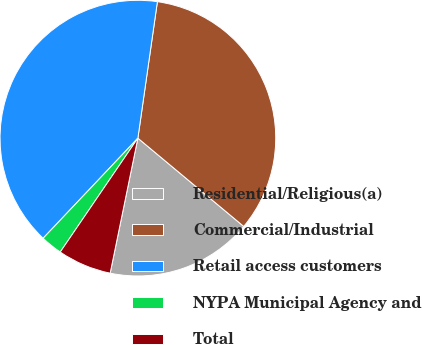<chart> <loc_0><loc_0><loc_500><loc_500><pie_chart><fcel>Residential/Religious(a)<fcel>Commercial/Industrial<fcel>Retail access customers<fcel>NYPA Municipal Agency and<fcel>Total<nl><fcel>17.16%<fcel>33.8%<fcel>40.2%<fcel>2.54%<fcel>6.3%<nl></chart> 